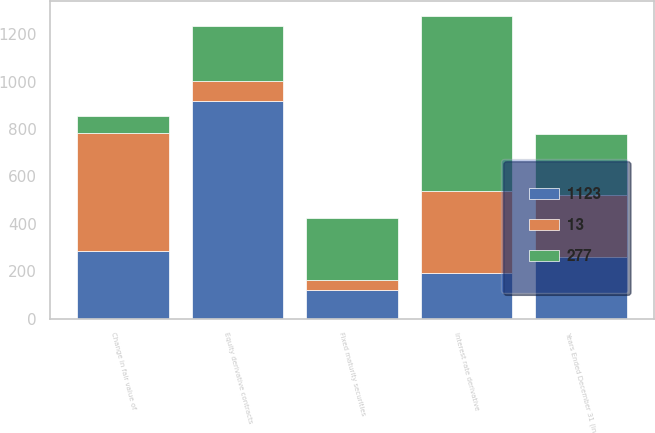Convert chart to OTSL. <chart><loc_0><loc_0><loc_500><loc_500><stacked_bar_chart><ecel><fcel>Years Ended December 31 (in<fcel>Change in fair value of<fcel>Fixed maturity securities<fcel>Interest rate derivative<fcel>Equity derivative contracts<nl><fcel>1123<fcel>260<fcel>286<fcel>120<fcel>194<fcel>919<nl><fcel>13<fcel>260<fcel>498<fcel>43<fcel>343<fcel>86<nl><fcel>277<fcel>260<fcel>72<fcel>260<fcel>742<fcel>230<nl></chart> 